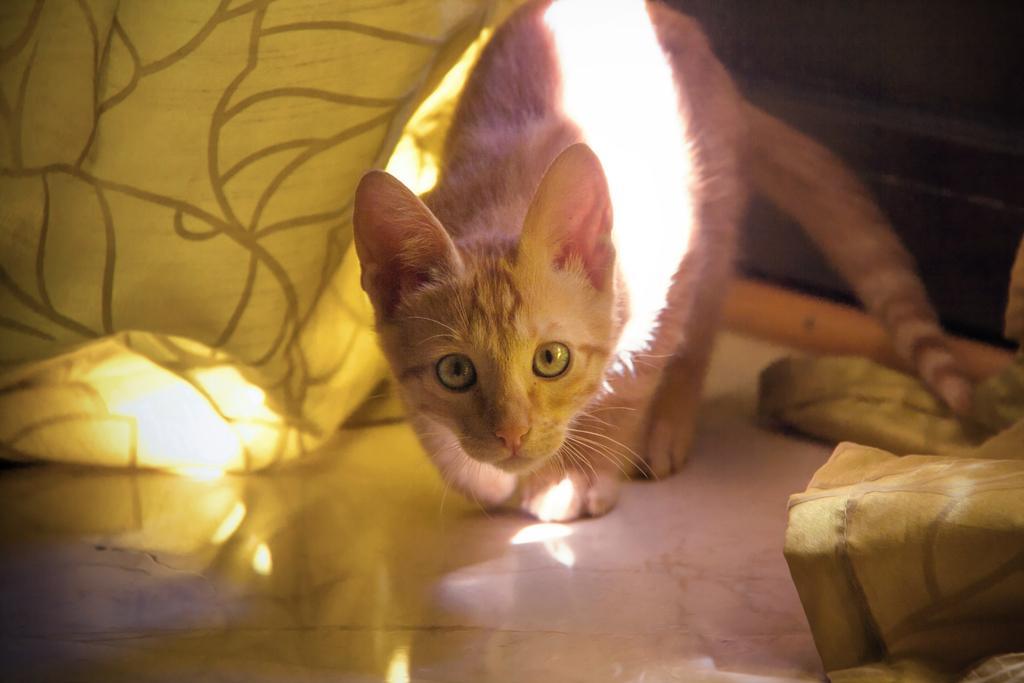Could you give a brief overview of what you see in this image? This is a cat white color cat on the floor. 